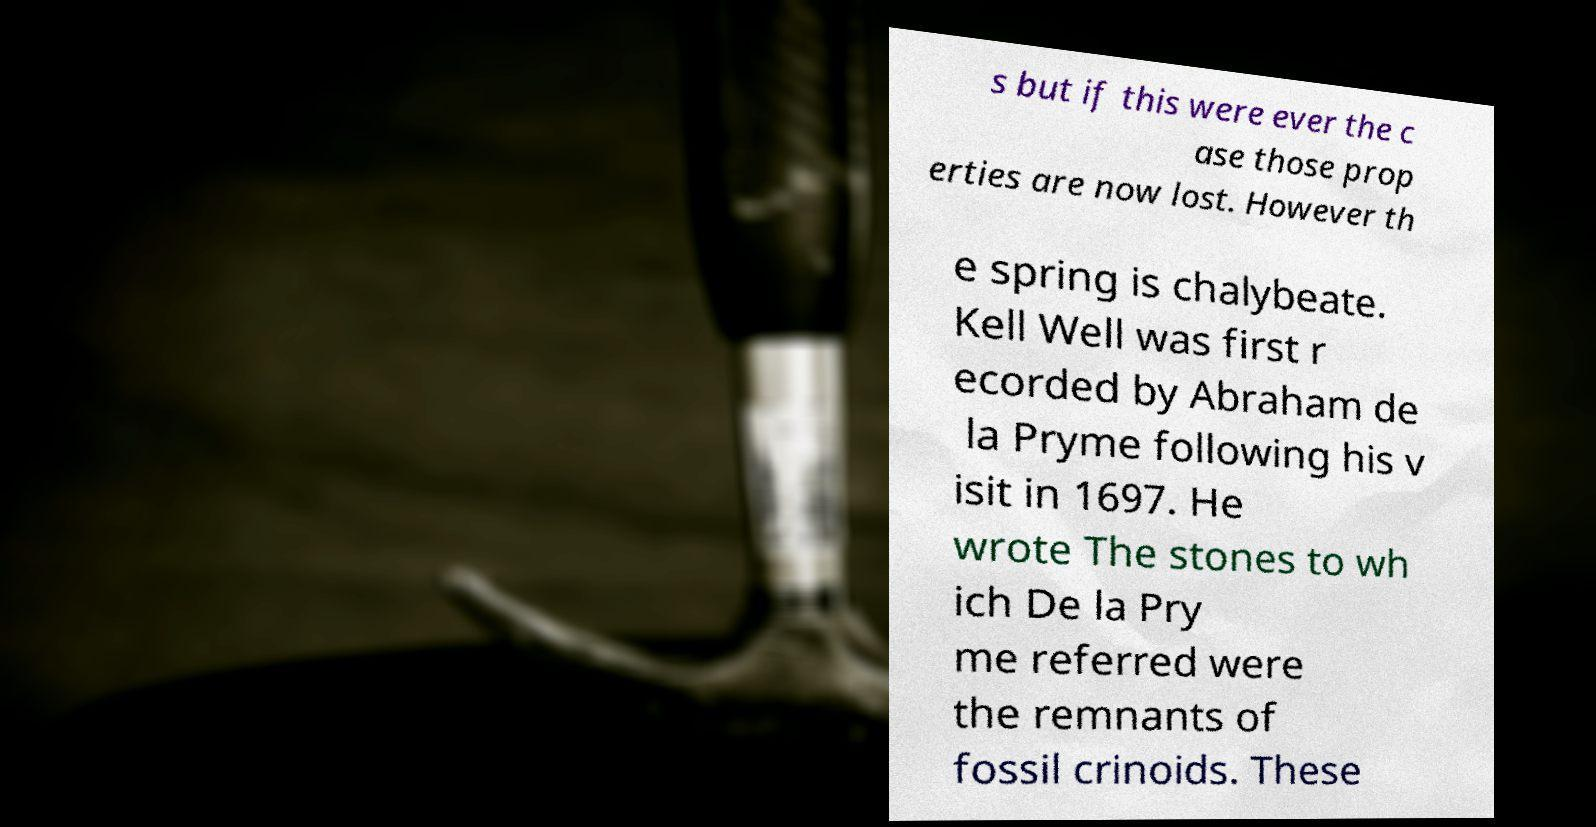I need the written content from this picture converted into text. Can you do that? s but if this were ever the c ase those prop erties are now lost. However th e spring is chalybeate. Kell Well was first r ecorded by Abraham de la Pryme following his v isit in 1697. He wrote The stones to wh ich De la Pry me referred were the remnants of fossil crinoids. These 